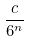<formula> <loc_0><loc_0><loc_500><loc_500>\frac { c } { 6 ^ { n } }</formula> 